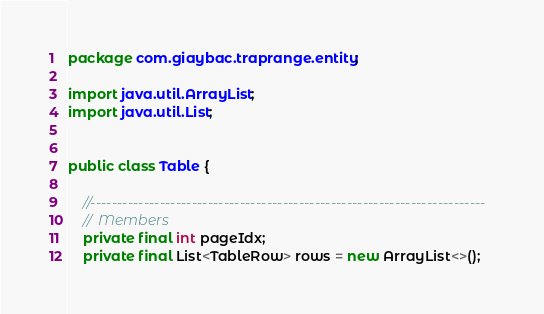Convert code to text. <code><loc_0><loc_0><loc_500><loc_500><_Java_>

package com.giaybac.traprange.entity;

import java.util.ArrayList;
import java.util.List;


public class Table {

    //--------------------------------------------------------------------------
    //  Members
    private final int pageIdx;
    private final List<TableRow> rows = new ArrayList<>();</code> 